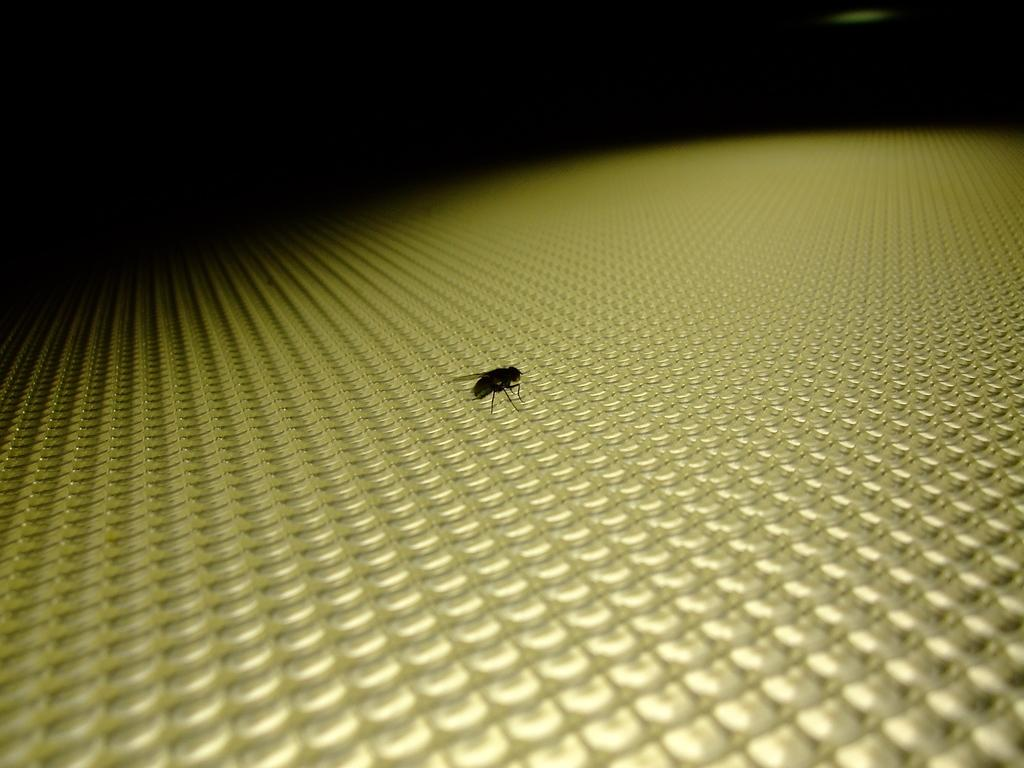What type of creature is present in the image? There is an insect in the image. What color is the surface on which the insect is located? The insect is on a yellow surface. What can be observed about the background of the image? The background of the image is dark. What type of animal can be seen walking through the airport in the image? There is no animal or airport present in the image; it features an insect on a yellow surface with a dark background. What is the insect using to smell the surroundings in the image? Insects do not have noses like humans, so there is no nose present in the image. 